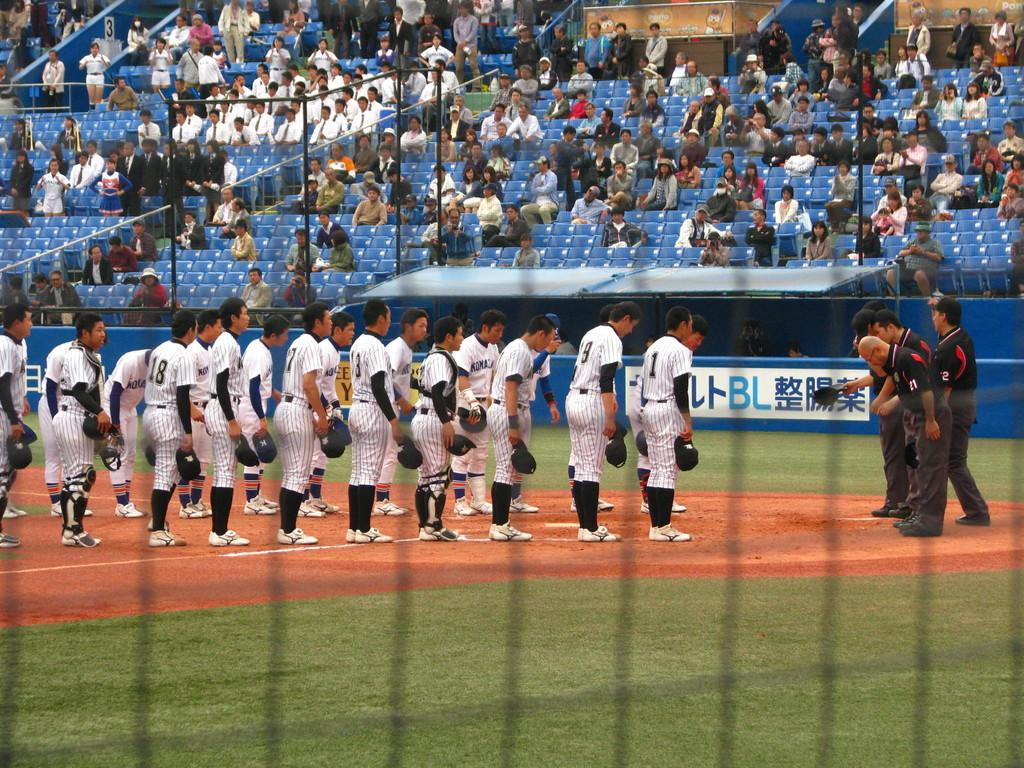Provide a one-sentence caption for the provided image. Player number 18 stands near the back of the line on the field. 